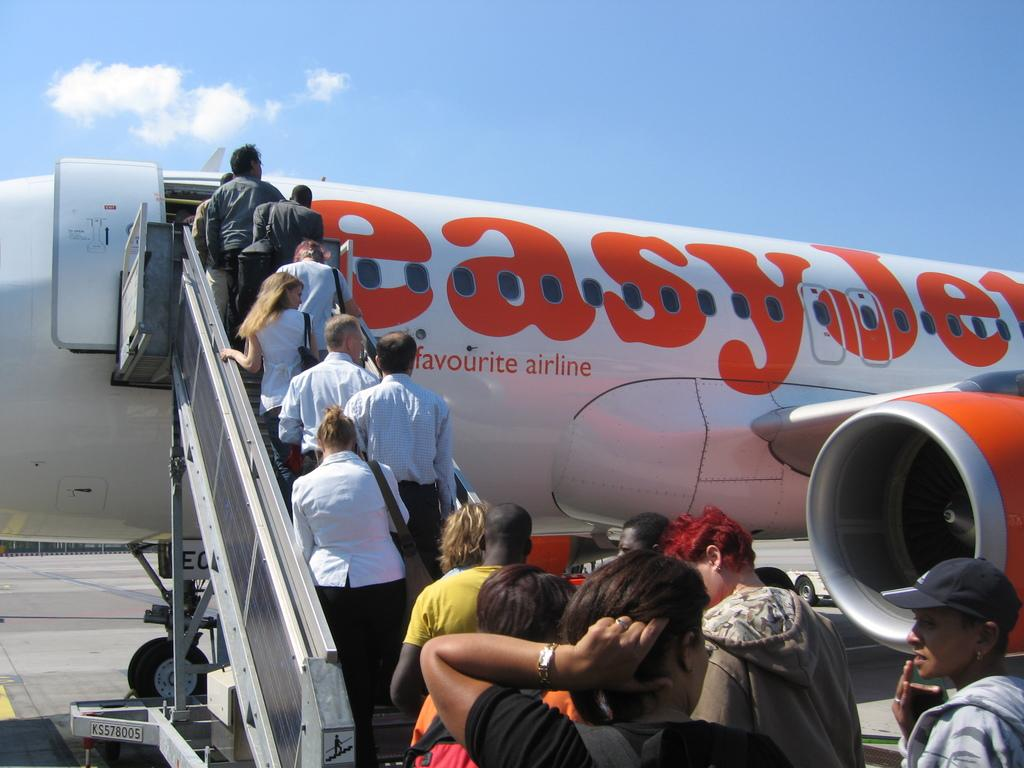<image>
Render a clear and concise summary of the photo. Passengers boarding a plane owned by Easy Jet. 